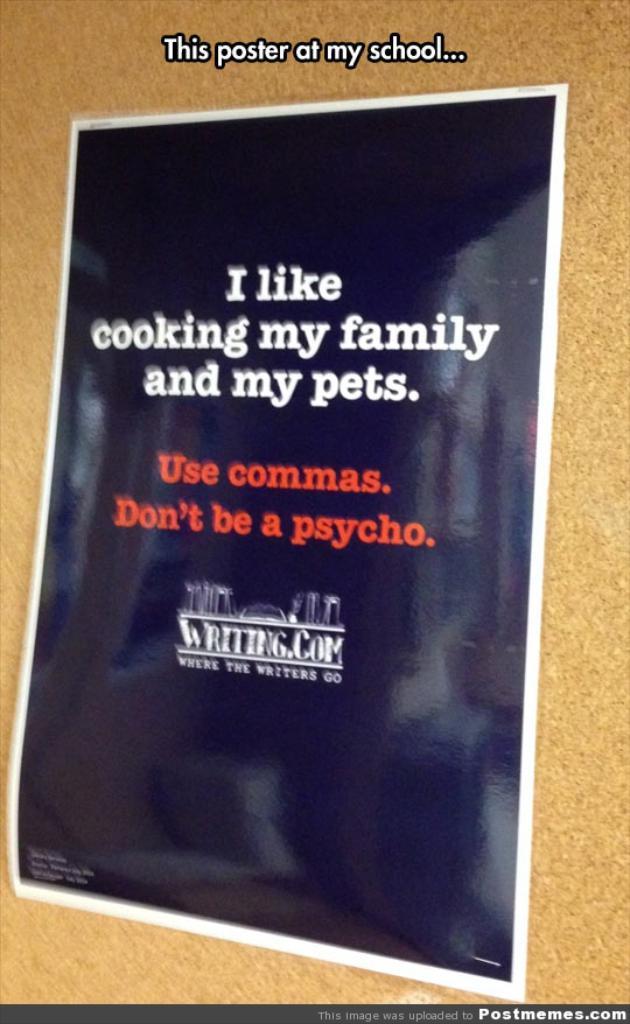What does the poster warn you to do?
Offer a terse response. Use commas. What is the first thing they like?
Provide a short and direct response. Cooking. 